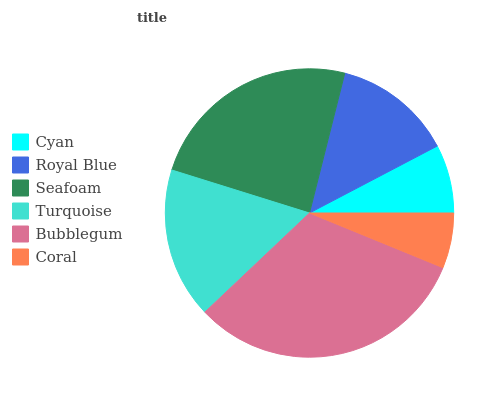Is Coral the minimum?
Answer yes or no. Yes. Is Bubblegum the maximum?
Answer yes or no. Yes. Is Royal Blue the minimum?
Answer yes or no. No. Is Royal Blue the maximum?
Answer yes or no. No. Is Royal Blue greater than Cyan?
Answer yes or no. Yes. Is Cyan less than Royal Blue?
Answer yes or no. Yes. Is Cyan greater than Royal Blue?
Answer yes or no. No. Is Royal Blue less than Cyan?
Answer yes or no. No. Is Turquoise the high median?
Answer yes or no. Yes. Is Royal Blue the low median?
Answer yes or no. Yes. Is Coral the high median?
Answer yes or no. No. Is Bubblegum the low median?
Answer yes or no. No. 